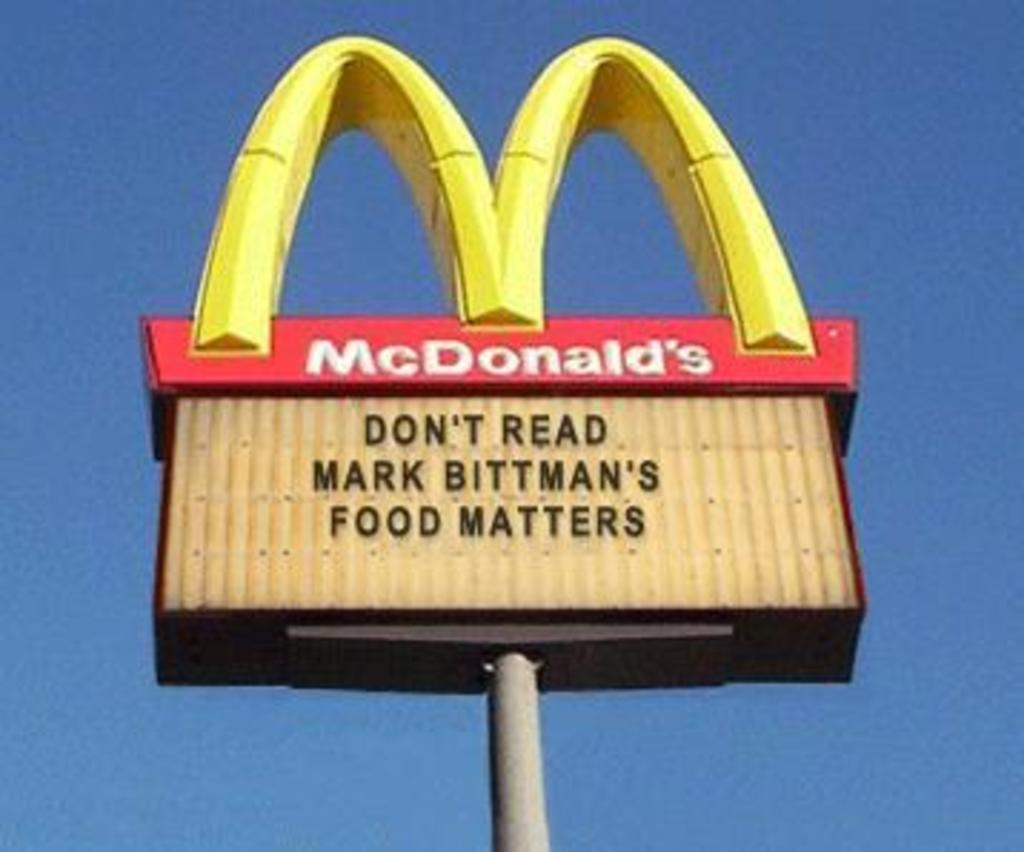<image>
Write a terse but informative summary of the picture. McDonald's sign telling you don't read Mark Bittman's food matters. 